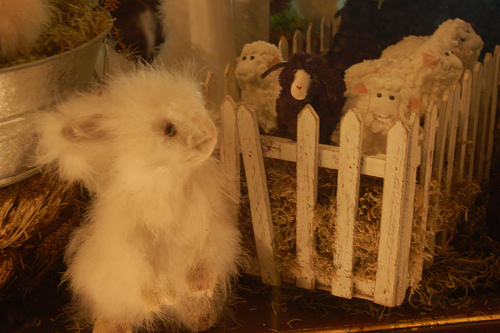<image>
Is there a sheep to the left of the sheep? Yes. From this viewpoint, the sheep is positioned to the left side relative to the sheep. Where is the toy in relation to the fence? Is it behind the fence? No. The toy is not behind the fence. From this viewpoint, the toy appears to be positioned elsewhere in the scene. Is there a sheep in front of the fence? No. The sheep is not in front of the fence. The spatial positioning shows a different relationship between these objects. 